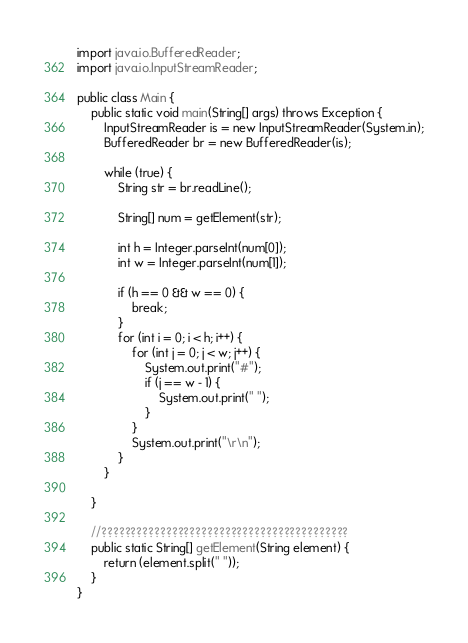Convert code to text. <code><loc_0><loc_0><loc_500><loc_500><_Java_>import java.io.BufferedReader;
import java.io.InputStreamReader;

public class Main {
	public static void main(String[] args) throws Exception {
		InputStreamReader is = new InputStreamReader(System.in);
		BufferedReader br = new BufferedReader(is);

		while (true) {
			String str = br.readLine();

			String[] num = getElement(str);

			int h = Integer.parseInt(num[0]);
			int w = Integer.parseInt(num[1]);

			if (h == 0 && w == 0) {
				break;
			}
			for (int i = 0; i < h; i++) {
				for (int j = 0; j < w; j++) {
					System.out.print("#");
					if (j == w - 1) {
						System.out.print(" ");
					}
				}
				System.out.print("\r\n");
			}
		}

	}

	//??????????????????????????????????????????
	public static String[] getElement(String element) {
		return (element.split(" "));
	}
}</code> 